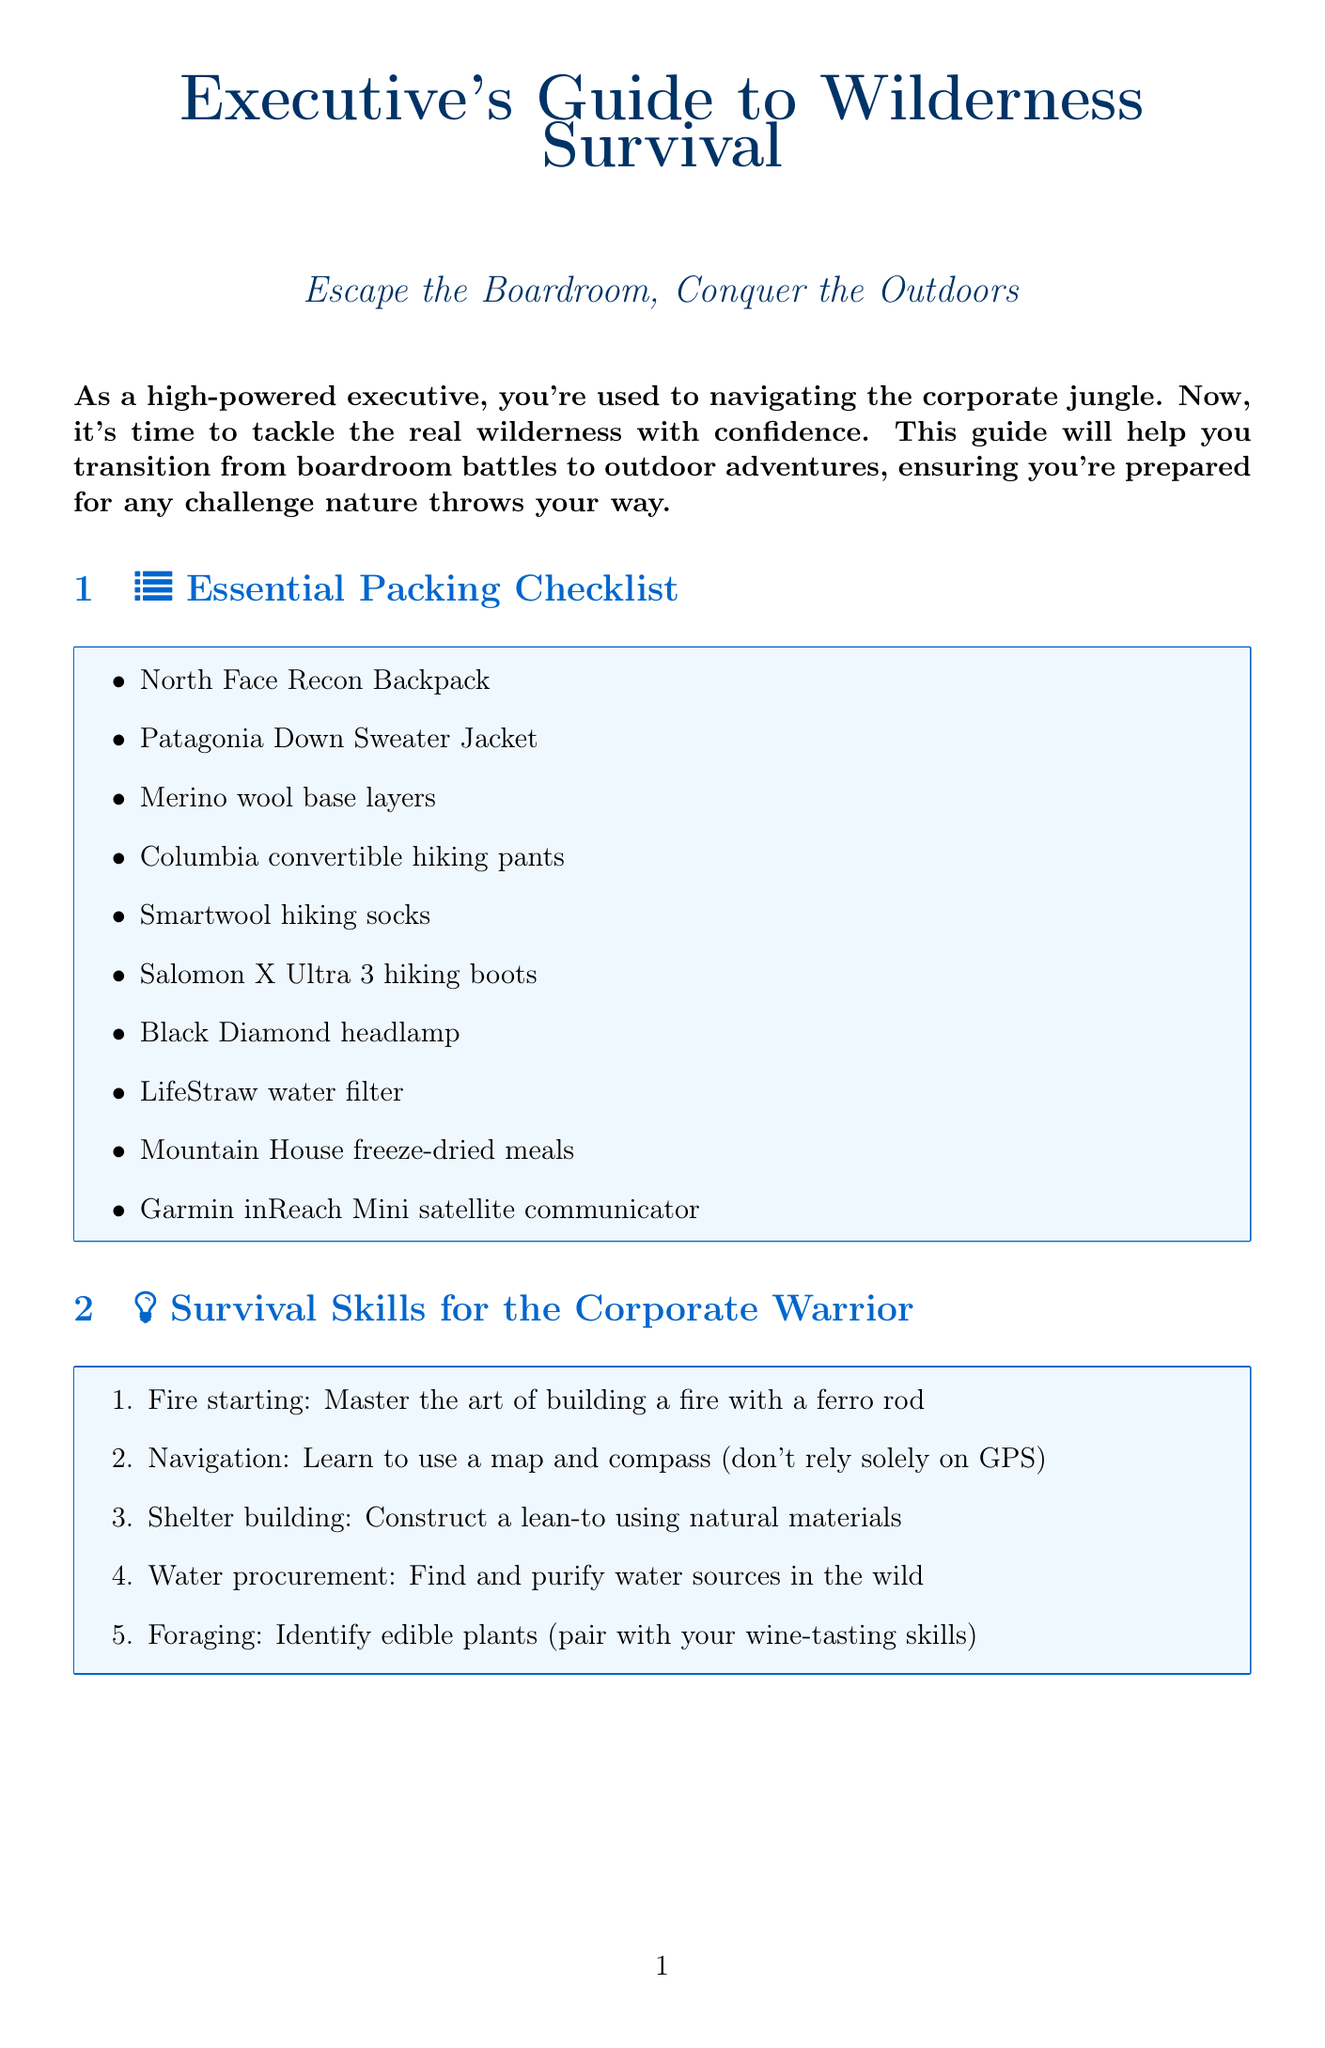What is the title of the newsletter? The title is listed at the beginning of the document, summarizing its focus on wilderness survival for executives.
Answer: Executive's Guide to Wilderness Survival: Escape the Boardroom, Conquer the Outdoors How many items are in the essential packing checklist? The essential packing checklist is clearly enumerated, providing a count of the items listed.
Answer: 10 What is the first item listed in the luxury items section? The document specifies the items in the luxury section in a numbered format, indicating the first listed item.
Answer: YETI Tundra 45 Cooler for keeping drinks chilled What skill involves building a fire with a ferro rod? The skills are numbered, and fire starting is described as a specific skill among others.
Answer: Fire starting Name one stress-busting outdoor activity mentioned. The document lists various outdoor activities aimed at reducing stress, providing several options.
Answer: Fly fishing in pristine mountain streams What is one emergency preparedness tip provided? The tips for emergency preparedness are listed sequentially, which can be referenced directly.
Answer: Always inform a trusted colleague of your trip itinerary How many wilderness retreats for executives are mentioned? The document lists various wilderness retreats specifically targeted at executives, which can be counted.
Answer: 5 Which item is suggested for charging devices while cooking? The document includes luxury items, specifying one that serves a dual function of cooking and charging.
Answer: BioLite CampStove 2+ What should you pack in case of unexpected delays? The document lists emergency preparedness tips that include specific items to pack for contingencies.
Answer: Extra food and water 